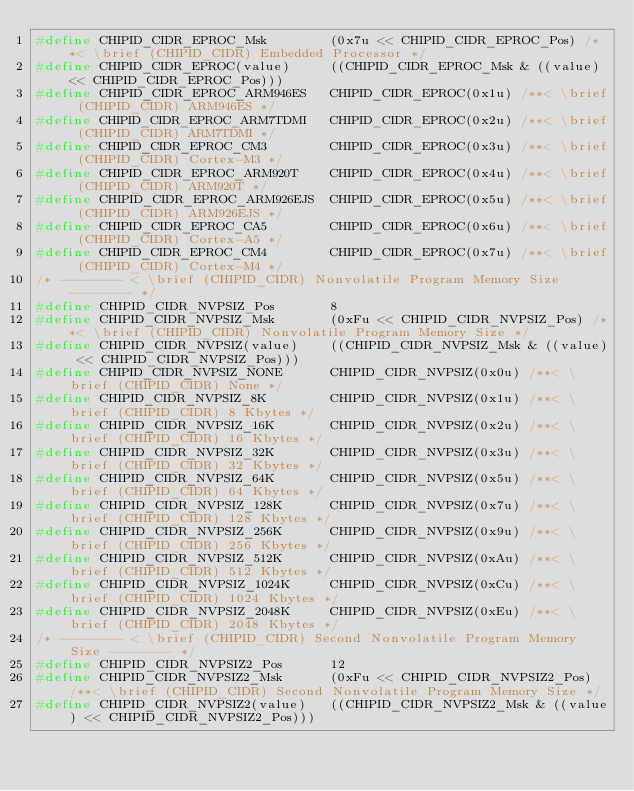<code> <loc_0><loc_0><loc_500><loc_500><_C_>#define CHIPID_CIDR_EPROC_Msk        (0x7u << CHIPID_CIDR_EPROC_Pos) /**< \brief (CHIPID_CIDR) Embedded Processor */
#define CHIPID_CIDR_EPROC(value)     ((CHIPID_CIDR_EPROC_Msk & ((value) << CHIPID_CIDR_EPROC_Pos)))
#define CHIPID_CIDR_EPROC_ARM946ES   CHIPID_CIDR_EPROC(0x1u) /**< \brief (CHIPID_CIDR) ARM946ES */
#define CHIPID_CIDR_EPROC_ARM7TDMI   CHIPID_CIDR_EPROC(0x2u) /**< \brief (CHIPID_CIDR) ARM7TDMI */
#define CHIPID_CIDR_EPROC_CM3        CHIPID_CIDR_EPROC(0x3u) /**< \brief (CHIPID_CIDR) Cortex-M3 */
#define CHIPID_CIDR_EPROC_ARM920T    CHIPID_CIDR_EPROC(0x4u) /**< \brief (CHIPID_CIDR) ARM920T */
#define CHIPID_CIDR_EPROC_ARM926EJS  CHIPID_CIDR_EPROC(0x5u) /**< \brief (CHIPID_CIDR) ARM926EJS */
#define CHIPID_CIDR_EPROC_CA5        CHIPID_CIDR_EPROC(0x6u) /**< \brief (CHIPID_CIDR) Cortex-A5 */
#define CHIPID_CIDR_EPROC_CM4        CHIPID_CIDR_EPROC(0x7u) /**< \brief (CHIPID_CIDR) Cortex-M4 */
/* -------- < \brief (CHIPID_CIDR) Nonvolatile Program Memory Size -------- */
#define CHIPID_CIDR_NVPSIZ_Pos       8
#define CHIPID_CIDR_NVPSIZ_Msk       (0xFu << CHIPID_CIDR_NVPSIZ_Pos) /**< \brief (CHIPID_CIDR) Nonvolatile Program Memory Size */
#define CHIPID_CIDR_NVPSIZ(value)    ((CHIPID_CIDR_NVPSIZ_Msk & ((value) << CHIPID_CIDR_NVPSIZ_Pos)))
#define CHIPID_CIDR_NVPSIZ_NONE      CHIPID_CIDR_NVPSIZ(0x0u) /**< \brief (CHIPID_CIDR) None */
#define CHIPID_CIDR_NVPSIZ_8K        CHIPID_CIDR_NVPSIZ(0x1u) /**< \brief (CHIPID_CIDR) 8 Kbytes */
#define CHIPID_CIDR_NVPSIZ_16K       CHIPID_CIDR_NVPSIZ(0x2u) /**< \brief (CHIPID_CIDR) 16 Kbytes */
#define CHIPID_CIDR_NVPSIZ_32K       CHIPID_CIDR_NVPSIZ(0x3u) /**< \brief (CHIPID_CIDR) 32 Kbytes */
#define CHIPID_CIDR_NVPSIZ_64K       CHIPID_CIDR_NVPSIZ(0x5u) /**< \brief (CHIPID_CIDR) 64 Kbytes */
#define CHIPID_CIDR_NVPSIZ_128K      CHIPID_CIDR_NVPSIZ(0x7u) /**< \brief (CHIPID_CIDR) 128 Kbytes */
#define CHIPID_CIDR_NVPSIZ_256K      CHIPID_CIDR_NVPSIZ(0x9u) /**< \brief (CHIPID_CIDR) 256 Kbytes */
#define CHIPID_CIDR_NVPSIZ_512K      CHIPID_CIDR_NVPSIZ(0xAu) /**< \brief (CHIPID_CIDR) 512 Kbytes */
#define CHIPID_CIDR_NVPSIZ_1024K     CHIPID_CIDR_NVPSIZ(0xCu) /**< \brief (CHIPID_CIDR) 1024 Kbytes */
#define CHIPID_CIDR_NVPSIZ_2048K     CHIPID_CIDR_NVPSIZ(0xEu) /**< \brief (CHIPID_CIDR) 2048 Kbytes */
/* -------- < \brief (CHIPID_CIDR) Second Nonvolatile Program Memory Size -------- */
#define CHIPID_CIDR_NVPSIZ2_Pos      12
#define CHIPID_CIDR_NVPSIZ2_Msk      (0xFu << CHIPID_CIDR_NVPSIZ2_Pos) /**< \brief (CHIPID_CIDR) Second Nonvolatile Program Memory Size */
#define CHIPID_CIDR_NVPSIZ2(value)   ((CHIPID_CIDR_NVPSIZ2_Msk & ((value) << CHIPID_CIDR_NVPSIZ2_Pos)))</code> 